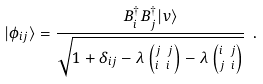Convert formula to latex. <formula><loc_0><loc_0><loc_500><loc_500>| \phi _ { i j } \rangle = \frac { B _ { i } ^ { \dag } B _ { j } ^ { \dag } | v \rangle } { \sqrt { 1 + \delta _ { i j } - \lambda \left ( ^ { j \ j } _ { i \ i } \right ) - \lambda \left ( ^ { i \ j } _ { j \ i } \right ) } } \ .</formula> 